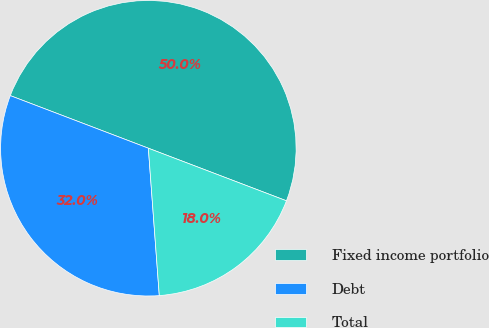Convert chart to OTSL. <chart><loc_0><loc_0><loc_500><loc_500><pie_chart><fcel>Fixed income portfolio<fcel>Debt<fcel>Total<nl><fcel>50.0%<fcel>31.97%<fcel>18.03%<nl></chart> 